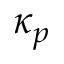Convert formula to latex. <formula><loc_0><loc_0><loc_500><loc_500>\kappa _ { p }</formula> 